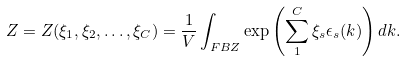<formula> <loc_0><loc_0><loc_500><loc_500>Z = Z ( \xi _ { 1 } , \xi _ { 2 } , \dots , \xi _ { C } ) = \frac { 1 } { V } \int _ { F B Z } \exp \left ( \sum _ { 1 } ^ { C } \xi _ { s } \epsilon _ { s } ( k ) \right ) d k .</formula> 